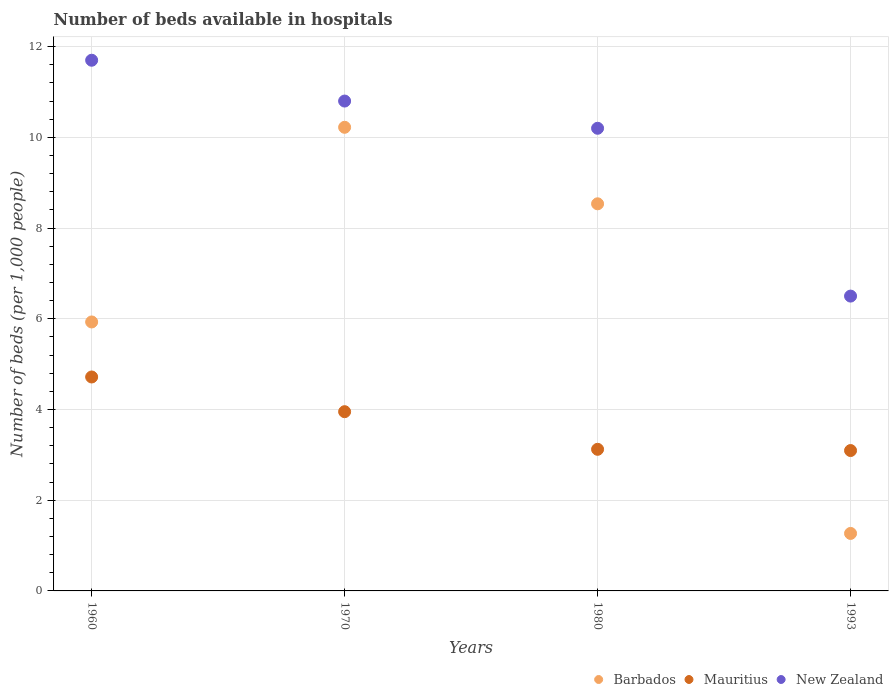How many different coloured dotlines are there?
Your response must be concise. 3. What is the number of beds in the hospiatls of in Mauritius in 1993?
Provide a short and direct response. 3.09. Across all years, what is the maximum number of beds in the hospiatls of in New Zealand?
Your response must be concise. 11.7. Across all years, what is the minimum number of beds in the hospiatls of in Mauritius?
Give a very brief answer. 3.09. In which year was the number of beds in the hospiatls of in New Zealand maximum?
Your answer should be very brief. 1960. In which year was the number of beds in the hospiatls of in Mauritius minimum?
Your answer should be very brief. 1993. What is the total number of beds in the hospiatls of in Barbados in the graph?
Your answer should be compact. 25.95. What is the difference between the number of beds in the hospiatls of in New Zealand in 1970 and that in 1980?
Your answer should be compact. 0.6. What is the difference between the number of beds in the hospiatls of in Mauritius in 1993 and the number of beds in the hospiatls of in New Zealand in 1970?
Your answer should be compact. -7.71. What is the average number of beds in the hospiatls of in Mauritius per year?
Give a very brief answer. 3.72. In the year 1960, what is the difference between the number of beds in the hospiatls of in Barbados and number of beds in the hospiatls of in Mauritius?
Your response must be concise. 1.21. What is the ratio of the number of beds in the hospiatls of in Barbados in 1980 to that in 1993?
Provide a succinct answer. 6.73. Is the number of beds in the hospiatls of in Mauritius in 1970 less than that in 1993?
Provide a succinct answer. No. Is the difference between the number of beds in the hospiatls of in Barbados in 1960 and 1970 greater than the difference between the number of beds in the hospiatls of in Mauritius in 1960 and 1970?
Ensure brevity in your answer.  No. What is the difference between the highest and the second highest number of beds in the hospiatls of in New Zealand?
Your answer should be very brief. 0.9. What is the difference between the highest and the lowest number of beds in the hospiatls of in Mauritius?
Provide a short and direct response. 1.62. In how many years, is the number of beds in the hospiatls of in New Zealand greater than the average number of beds in the hospiatls of in New Zealand taken over all years?
Ensure brevity in your answer.  3. Is the sum of the number of beds in the hospiatls of in Barbados in 1970 and 1993 greater than the maximum number of beds in the hospiatls of in New Zealand across all years?
Provide a short and direct response. No. Is the number of beds in the hospiatls of in Mauritius strictly greater than the number of beds in the hospiatls of in New Zealand over the years?
Your answer should be compact. No. How many dotlines are there?
Give a very brief answer. 3. How many years are there in the graph?
Offer a very short reply. 4. Does the graph contain any zero values?
Keep it short and to the point. No. Does the graph contain grids?
Ensure brevity in your answer.  Yes. How many legend labels are there?
Make the answer very short. 3. What is the title of the graph?
Keep it short and to the point. Number of beds available in hospitals. Does "Portugal" appear as one of the legend labels in the graph?
Your answer should be compact. No. What is the label or title of the X-axis?
Make the answer very short. Years. What is the label or title of the Y-axis?
Provide a short and direct response. Number of beds (per 1,0 people). What is the Number of beds (per 1,000 people) in Barbados in 1960?
Your answer should be very brief. 5.93. What is the Number of beds (per 1,000 people) of Mauritius in 1960?
Ensure brevity in your answer.  4.72. What is the Number of beds (per 1,000 people) in New Zealand in 1960?
Provide a succinct answer. 11.7. What is the Number of beds (per 1,000 people) of Barbados in 1970?
Your answer should be very brief. 10.22. What is the Number of beds (per 1,000 people) in Mauritius in 1970?
Your response must be concise. 3.95. What is the Number of beds (per 1,000 people) in New Zealand in 1970?
Your answer should be compact. 10.8. What is the Number of beds (per 1,000 people) in Barbados in 1980?
Make the answer very short. 8.53. What is the Number of beds (per 1,000 people) of Mauritius in 1980?
Your answer should be compact. 3.12. What is the Number of beds (per 1,000 people) in New Zealand in 1980?
Offer a terse response. 10.2. What is the Number of beds (per 1,000 people) in Barbados in 1993?
Your answer should be very brief. 1.27. What is the Number of beds (per 1,000 people) in Mauritius in 1993?
Your answer should be compact. 3.09. What is the Number of beds (per 1,000 people) in New Zealand in 1993?
Offer a very short reply. 6.5. Across all years, what is the maximum Number of beds (per 1,000 people) of Barbados?
Offer a very short reply. 10.22. Across all years, what is the maximum Number of beds (per 1,000 people) of Mauritius?
Your response must be concise. 4.72. Across all years, what is the maximum Number of beds (per 1,000 people) in New Zealand?
Give a very brief answer. 11.7. Across all years, what is the minimum Number of beds (per 1,000 people) of Barbados?
Your response must be concise. 1.27. Across all years, what is the minimum Number of beds (per 1,000 people) of Mauritius?
Offer a very short reply. 3.09. Across all years, what is the minimum Number of beds (per 1,000 people) in New Zealand?
Make the answer very short. 6.5. What is the total Number of beds (per 1,000 people) of Barbados in the graph?
Your answer should be compact. 25.95. What is the total Number of beds (per 1,000 people) of Mauritius in the graph?
Your answer should be compact. 14.89. What is the total Number of beds (per 1,000 people) of New Zealand in the graph?
Your answer should be very brief. 39.2. What is the difference between the Number of beds (per 1,000 people) in Barbados in 1960 and that in 1970?
Keep it short and to the point. -4.29. What is the difference between the Number of beds (per 1,000 people) of Mauritius in 1960 and that in 1970?
Give a very brief answer. 0.77. What is the difference between the Number of beds (per 1,000 people) in Barbados in 1960 and that in 1980?
Offer a terse response. -2.6. What is the difference between the Number of beds (per 1,000 people) of Mauritius in 1960 and that in 1980?
Offer a very short reply. 1.59. What is the difference between the Number of beds (per 1,000 people) in Barbados in 1960 and that in 1993?
Make the answer very short. 4.66. What is the difference between the Number of beds (per 1,000 people) in Mauritius in 1960 and that in 1993?
Give a very brief answer. 1.62. What is the difference between the Number of beds (per 1,000 people) in New Zealand in 1960 and that in 1993?
Provide a succinct answer. 5.2. What is the difference between the Number of beds (per 1,000 people) of Barbados in 1970 and that in 1980?
Keep it short and to the point. 1.69. What is the difference between the Number of beds (per 1,000 people) of Mauritius in 1970 and that in 1980?
Give a very brief answer. 0.83. What is the difference between the Number of beds (per 1,000 people) in Barbados in 1970 and that in 1993?
Your answer should be very brief. 8.95. What is the difference between the Number of beds (per 1,000 people) in Mauritius in 1970 and that in 1993?
Offer a very short reply. 0.86. What is the difference between the Number of beds (per 1,000 people) in Barbados in 1980 and that in 1993?
Keep it short and to the point. 7.27. What is the difference between the Number of beds (per 1,000 people) in Mauritius in 1980 and that in 1993?
Offer a very short reply. 0.03. What is the difference between the Number of beds (per 1,000 people) of New Zealand in 1980 and that in 1993?
Provide a short and direct response. 3.7. What is the difference between the Number of beds (per 1,000 people) of Barbados in 1960 and the Number of beds (per 1,000 people) of Mauritius in 1970?
Keep it short and to the point. 1.98. What is the difference between the Number of beds (per 1,000 people) of Barbados in 1960 and the Number of beds (per 1,000 people) of New Zealand in 1970?
Your answer should be very brief. -4.87. What is the difference between the Number of beds (per 1,000 people) of Mauritius in 1960 and the Number of beds (per 1,000 people) of New Zealand in 1970?
Offer a very short reply. -6.08. What is the difference between the Number of beds (per 1,000 people) in Barbados in 1960 and the Number of beds (per 1,000 people) in Mauritius in 1980?
Provide a succinct answer. 2.81. What is the difference between the Number of beds (per 1,000 people) in Barbados in 1960 and the Number of beds (per 1,000 people) in New Zealand in 1980?
Offer a very short reply. -4.27. What is the difference between the Number of beds (per 1,000 people) in Mauritius in 1960 and the Number of beds (per 1,000 people) in New Zealand in 1980?
Ensure brevity in your answer.  -5.48. What is the difference between the Number of beds (per 1,000 people) in Barbados in 1960 and the Number of beds (per 1,000 people) in Mauritius in 1993?
Provide a succinct answer. 2.83. What is the difference between the Number of beds (per 1,000 people) in Barbados in 1960 and the Number of beds (per 1,000 people) in New Zealand in 1993?
Your answer should be compact. -0.57. What is the difference between the Number of beds (per 1,000 people) in Mauritius in 1960 and the Number of beds (per 1,000 people) in New Zealand in 1993?
Ensure brevity in your answer.  -1.78. What is the difference between the Number of beds (per 1,000 people) of Barbados in 1970 and the Number of beds (per 1,000 people) of Mauritius in 1980?
Your answer should be very brief. 7.1. What is the difference between the Number of beds (per 1,000 people) of Barbados in 1970 and the Number of beds (per 1,000 people) of New Zealand in 1980?
Provide a succinct answer. 0.02. What is the difference between the Number of beds (per 1,000 people) of Mauritius in 1970 and the Number of beds (per 1,000 people) of New Zealand in 1980?
Offer a terse response. -6.25. What is the difference between the Number of beds (per 1,000 people) in Barbados in 1970 and the Number of beds (per 1,000 people) in Mauritius in 1993?
Offer a very short reply. 7.13. What is the difference between the Number of beds (per 1,000 people) of Barbados in 1970 and the Number of beds (per 1,000 people) of New Zealand in 1993?
Provide a short and direct response. 3.72. What is the difference between the Number of beds (per 1,000 people) in Mauritius in 1970 and the Number of beds (per 1,000 people) in New Zealand in 1993?
Ensure brevity in your answer.  -2.55. What is the difference between the Number of beds (per 1,000 people) in Barbados in 1980 and the Number of beds (per 1,000 people) in Mauritius in 1993?
Your response must be concise. 5.44. What is the difference between the Number of beds (per 1,000 people) of Barbados in 1980 and the Number of beds (per 1,000 people) of New Zealand in 1993?
Provide a short and direct response. 2.03. What is the difference between the Number of beds (per 1,000 people) of Mauritius in 1980 and the Number of beds (per 1,000 people) of New Zealand in 1993?
Offer a very short reply. -3.38. What is the average Number of beds (per 1,000 people) in Barbados per year?
Make the answer very short. 6.49. What is the average Number of beds (per 1,000 people) in Mauritius per year?
Your answer should be compact. 3.72. What is the average Number of beds (per 1,000 people) of New Zealand per year?
Keep it short and to the point. 9.8. In the year 1960, what is the difference between the Number of beds (per 1,000 people) in Barbados and Number of beds (per 1,000 people) in Mauritius?
Keep it short and to the point. 1.21. In the year 1960, what is the difference between the Number of beds (per 1,000 people) in Barbados and Number of beds (per 1,000 people) in New Zealand?
Provide a short and direct response. -5.77. In the year 1960, what is the difference between the Number of beds (per 1,000 people) in Mauritius and Number of beds (per 1,000 people) in New Zealand?
Offer a very short reply. -6.98. In the year 1970, what is the difference between the Number of beds (per 1,000 people) in Barbados and Number of beds (per 1,000 people) in Mauritius?
Offer a terse response. 6.27. In the year 1970, what is the difference between the Number of beds (per 1,000 people) of Barbados and Number of beds (per 1,000 people) of New Zealand?
Your response must be concise. -0.58. In the year 1970, what is the difference between the Number of beds (per 1,000 people) in Mauritius and Number of beds (per 1,000 people) in New Zealand?
Your answer should be compact. -6.85. In the year 1980, what is the difference between the Number of beds (per 1,000 people) of Barbados and Number of beds (per 1,000 people) of Mauritius?
Your response must be concise. 5.41. In the year 1980, what is the difference between the Number of beds (per 1,000 people) in Barbados and Number of beds (per 1,000 people) in New Zealand?
Offer a terse response. -1.67. In the year 1980, what is the difference between the Number of beds (per 1,000 people) in Mauritius and Number of beds (per 1,000 people) in New Zealand?
Your answer should be compact. -7.08. In the year 1993, what is the difference between the Number of beds (per 1,000 people) in Barbados and Number of beds (per 1,000 people) in Mauritius?
Provide a succinct answer. -1.83. In the year 1993, what is the difference between the Number of beds (per 1,000 people) of Barbados and Number of beds (per 1,000 people) of New Zealand?
Offer a very short reply. -5.23. In the year 1993, what is the difference between the Number of beds (per 1,000 people) in Mauritius and Number of beds (per 1,000 people) in New Zealand?
Give a very brief answer. -3.41. What is the ratio of the Number of beds (per 1,000 people) of Barbados in 1960 to that in 1970?
Your response must be concise. 0.58. What is the ratio of the Number of beds (per 1,000 people) of Mauritius in 1960 to that in 1970?
Offer a very short reply. 1.19. What is the ratio of the Number of beds (per 1,000 people) in Barbados in 1960 to that in 1980?
Provide a short and direct response. 0.69. What is the ratio of the Number of beds (per 1,000 people) of Mauritius in 1960 to that in 1980?
Your answer should be compact. 1.51. What is the ratio of the Number of beds (per 1,000 people) of New Zealand in 1960 to that in 1980?
Keep it short and to the point. 1.15. What is the ratio of the Number of beds (per 1,000 people) of Barbados in 1960 to that in 1993?
Your answer should be compact. 4.68. What is the ratio of the Number of beds (per 1,000 people) of Mauritius in 1960 to that in 1993?
Keep it short and to the point. 1.52. What is the ratio of the Number of beds (per 1,000 people) of Barbados in 1970 to that in 1980?
Provide a short and direct response. 1.2. What is the ratio of the Number of beds (per 1,000 people) of Mauritius in 1970 to that in 1980?
Provide a short and direct response. 1.27. What is the ratio of the Number of beds (per 1,000 people) in New Zealand in 1970 to that in 1980?
Your response must be concise. 1.06. What is the ratio of the Number of beds (per 1,000 people) of Barbados in 1970 to that in 1993?
Give a very brief answer. 8.06. What is the ratio of the Number of beds (per 1,000 people) of Mauritius in 1970 to that in 1993?
Make the answer very short. 1.28. What is the ratio of the Number of beds (per 1,000 people) of New Zealand in 1970 to that in 1993?
Your answer should be compact. 1.66. What is the ratio of the Number of beds (per 1,000 people) of Barbados in 1980 to that in 1993?
Offer a very short reply. 6.73. What is the ratio of the Number of beds (per 1,000 people) in Mauritius in 1980 to that in 1993?
Provide a short and direct response. 1.01. What is the ratio of the Number of beds (per 1,000 people) in New Zealand in 1980 to that in 1993?
Your answer should be very brief. 1.57. What is the difference between the highest and the second highest Number of beds (per 1,000 people) of Barbados?
Your answer should be very brief. 1.69. What is the difference between the highest and the second highest Number of beds (per 1,000 people) in Mauritius?
Offer a terse response. 0.77. What is the difference between the highest and the second highest Number of beds (per 1,000 people) in New Zealand?
Your answer should be very brief. 0.9. What is the difference between the highest and the lowest Number of beds (per 1,000 people) of Barbados?
Your answer should be compact. 8.95. What is the difference between the highest and the lowest Number of beds (per 1,000 people) of Mauritius?
Your response must be concise. 1.62. What is the difference between the highest and the lowest Number of beds (per 1,000 people) in New Zealand?
Offer a very short reply. 5.2. 